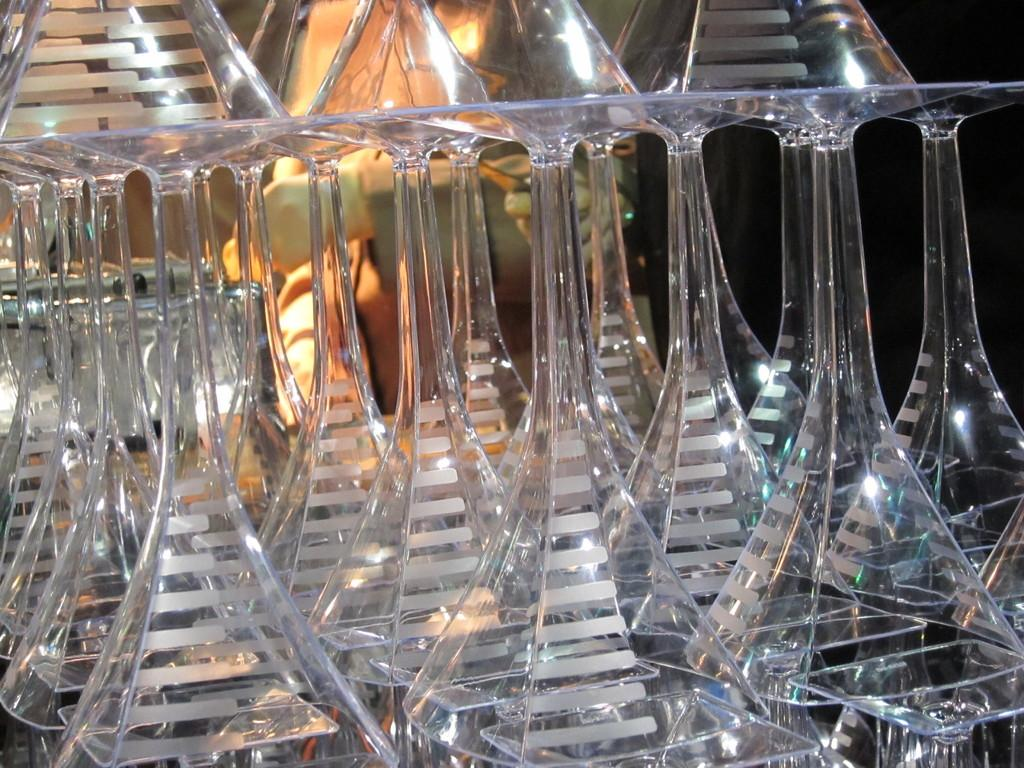What objects are in the foreground of the image? There are glasses in the foreground of the image. Where are the glasses located? The glasses appear to be placed on a table. What can be seen in the background of the image? There are other objects visible in the background of the image. What type of potatoes can be seen being distributed in the image? There are no potatoes or distribution visible in the image; it only features glasses placed on a table. 